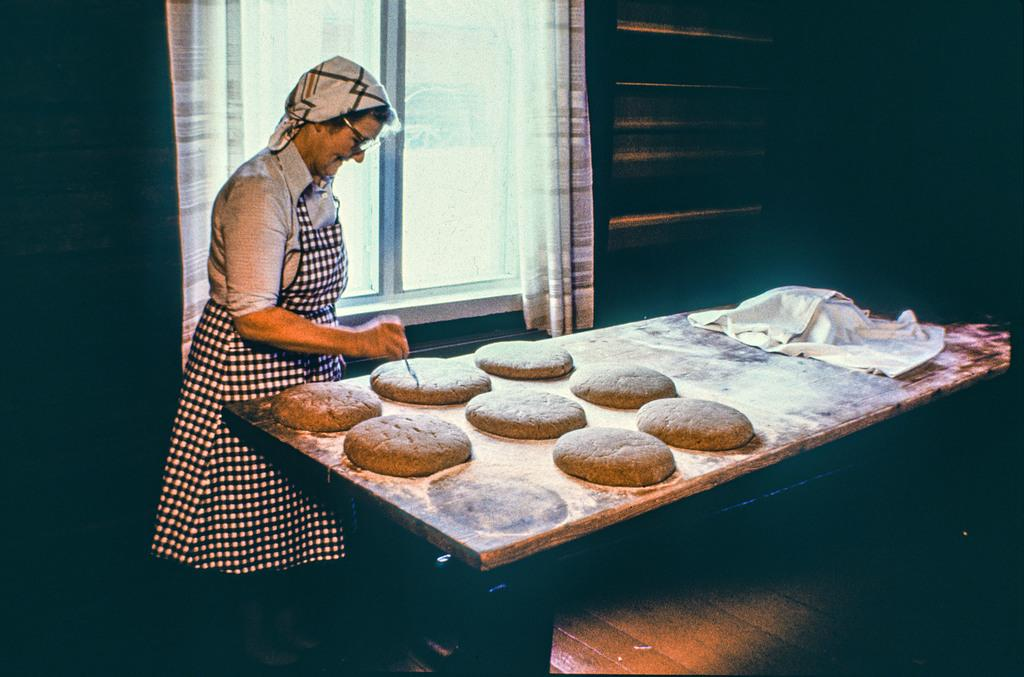Who is the main subject in the image? There is a woman in the image. What is the woman doing in the image? The woman is making food. What can be seen in the background of the image? There are windows and curtains on the wall in the background of the image. What is the woman's condition in the image? The provided facts do not mention any specific condition of the woman in the image. What does the woman desire in the image? The provided facts do not mention any specific desires of the woman in the image. 